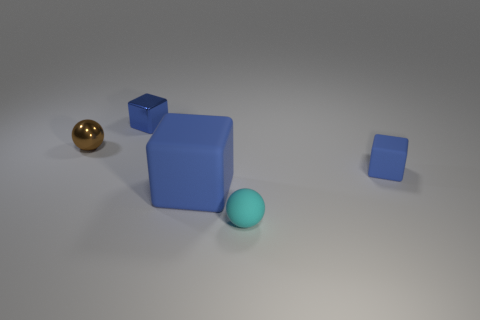Is there anything else that has the same color as the large rubber thing?
Give a very brief answer. Yes. How big is the brown shiny sphere?
Keep it short and to the point. Small. There is a ball that is to the left of the shiny block; is it the same size as the tiny cyan matte sphere?
Ensure brevity in your answer.  Yes. What is the shape of the tiny blue thing that is behind the metallic object that is to the left of the blue cube behind the tiny brown thing?
Your response must be concise. Cube. How many objects are either small blue matte blocks or tiny shiny balls that are in front of the blue shiny thing?
Ensure brevity in your answer.  2. There is a sphere that is behind the tiny cyan rubber object; what is its size?
Make the answer very short. Small. What shape is the small shiny thing that is the same color as the big cube?
Offer a very short reply. Cube. Do the cyan sphere and the tiny block that is behind the metal sphere have the same material?
Offer a terse response. No. What number of blue things are to the right of the rubber block that is left of the blue matte thing behind the large rubber thing?
Keep it short and to the point. 1. How many cyan objects are either large metal cylinders or small matte objects?
Make the answer very short. 1. 